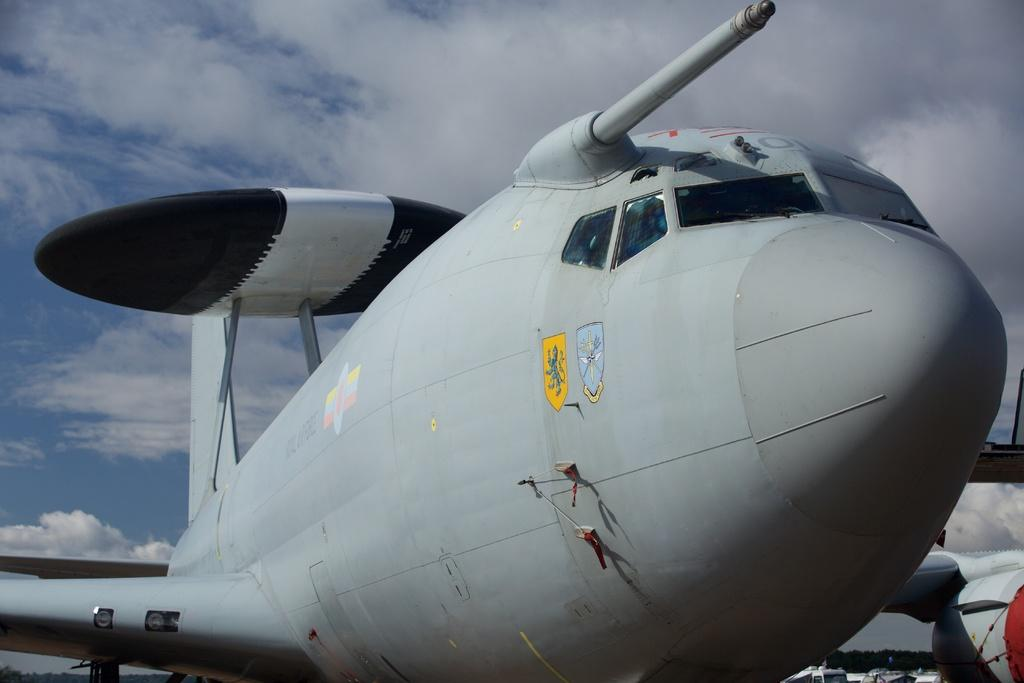What is the main subject of the picture? The main subject of the picture is an aircraft. What can be seen in the background of the picture? There are trees and a cloudy sky in the background of the picture. What type of advice can be seen written on the aircraft's wing in the image? There is no advice written on the aircraft's wing in the image. What brand of toothpaste is being advertised on the aircraft in the image? There is no toothpaste or advertisement present on the aircraft in the image. 